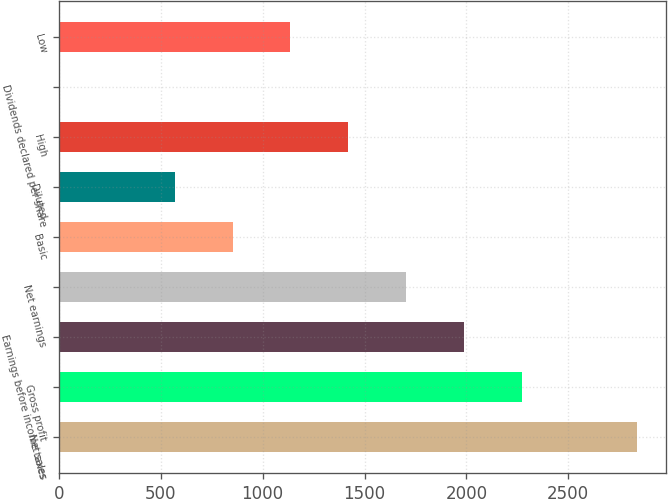Convert chart. <chart><loc_0><loc_0><loc_500><loc_500><bar_chart><fcel>Net sales<fcel>Gross profit<fcel>Earnings before income taxes<fcel>Net earnings<fcel>Basic<fcel>Diluted<fcel>High<fcel>Dividends declared per share<fcel>Low<nl><fcel>2840<fcel>2272.1<fcel>1988.13<fcel>1704.16<fcel>852.25<fcel>568.28<fcel>1420.19<fcel>0.34<fcel>1136.22<nl></chart> 